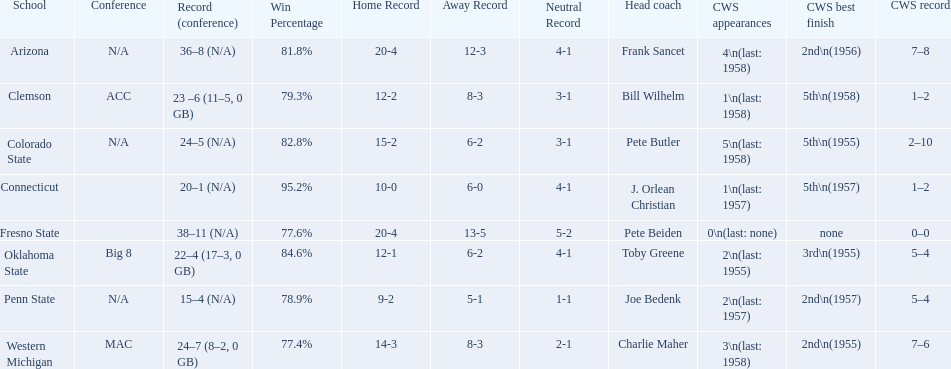What was the least amount of wins recorded by the losingest team? 15–4 (N/A). Which team held this record? Penn State. 